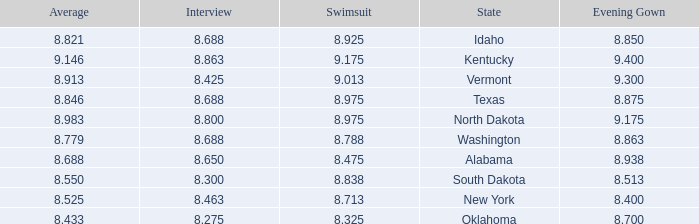What is the lowest average of the contestant with an interview of 8.275 and an evening gown bigger than 8.7? None. 